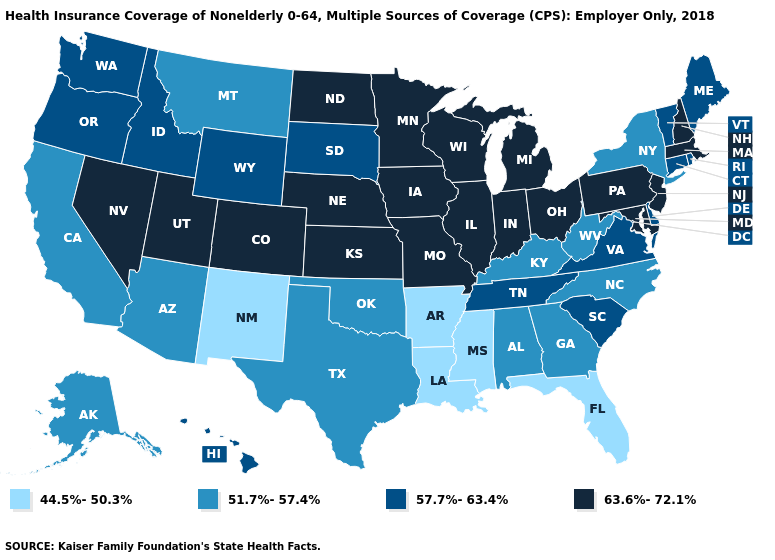What is the value of Arkansas?
Keep it brief. 44.5%-50.3%. What is the value of Kentucky?
Keep it brief. 51.7%-57.4%. What is the lowest value in the USA?
Short answer required. 44.5%-50.3%. Which states hav the highest value in the West?
Write a very short answer. Colorado, Nevada, Utah. Name the states that have a value in the range 57.7%-63.4%?
Quick response, please. Connecticut, Delaware, Hawaii, Idaho, Maine, Oregon, Rhode Island, South Carolina, South Dakota, Tennessee, Vermont, Virginia, Washington, Wyoming. Name the states that have a value in the range 44.5%-50.3%?
Answer briefly. Arkansas, Florida, Louisiana, Mississippi, New Mexico. Which states hav the highest value in the MidWest?
Write a very short answer. Illinois, Indiana, Iowa, Kansas, Michigan, Minnesota, Missouri, Nebraska, North Dakota, Ohio, Wisconsin. Which states have the lowest value in the South?
Concise answer only. Arkansas, Florida, Louisiana, Mississippi. Among the states that border Nebraska , does Kansas have the highest value?
Write a very short answer. Yes. Name the states that have a value in the range 63.6%-72.1%?
Quick response, please. Colorado, Illinois, Indiana, Iowa, Kansas, Maryland, Massachusetts, Michigan, Minnesota, Missouri, Nebraska, Nevada, New Hampshire, New Jersey, North Dakota, Ohio, Pennsylvania, Utah, Wisconsin. Name the states that have a value in the range 63.6%-72.1%?
Answer briefly. Colorado, Illinois, Indiana, Iowa, Kansas, Maryland, Massachusetts, Michigan, Minnesota, Missouri, Nebraska, Nevada, New Hampshire, New Jersey, North Dakota, Ohio, Pennsylvania, Utah, Wisconsin. Does Montana have the same value as Georgia?
Answer briefly. Yes. Which states have the highest value in the USA?
Quick response, please. Colorado, Illinois, Indiana, Iowa, Kansas, Maryland, Massachusetts, Michigan, Minnesota, Missouri, Nebraska, Nevada, New Hampshire, New Jersey, North Dakota, Ohio, Pennsylvania, Utah, Wisconsin. What is the highest value in the USA?
Write a very short answer. 63.6%-72.1%. What is the lowest value in the USA?
Quick response, please. 44.5%-50.3%. 